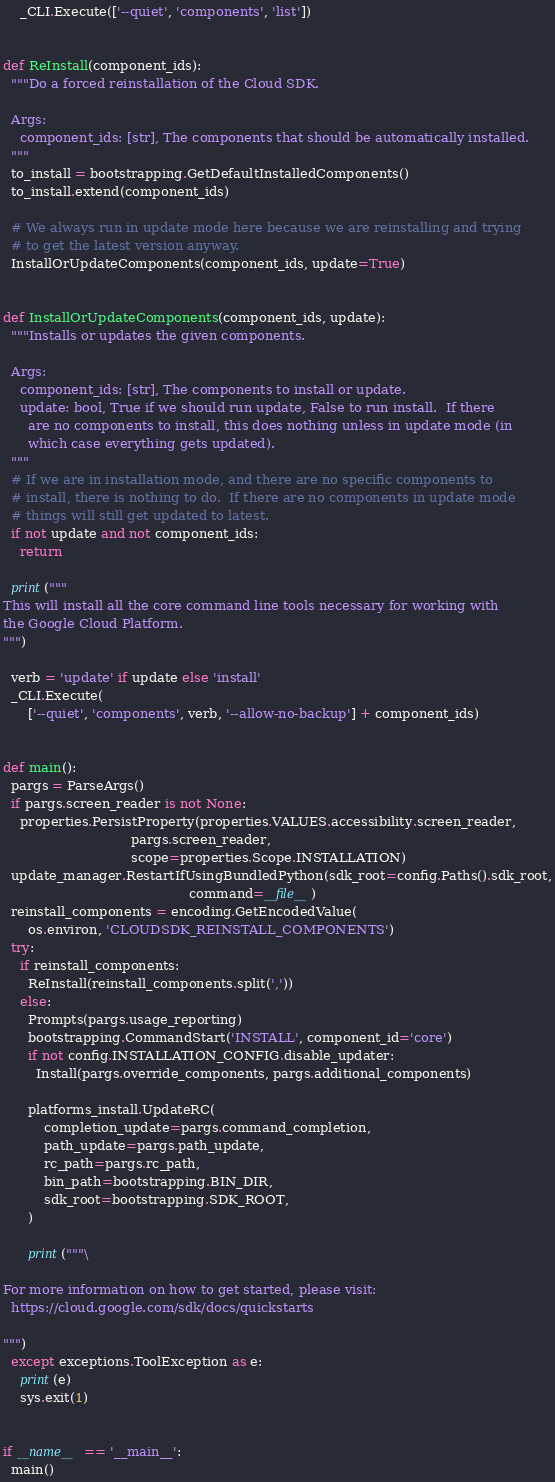Convert code to text. <code><loc_0><loc_0><loc_500><loc_500><_Python_>    _CLI.Execute(['--quiet', 'components', 'list'])


def ReInstall(component_ids):
  """Do a forced reinstallation of the Cloud SDK.

  Args:
    component_ids: [str], The components that should be automatically installed.
  """
  to_install = bootstrapping.GetDefaultInstalledComponents()
  to_install.extend(component_ids)

  # We always run in update mode here because we are reinstalling and trying
  # to get the latest version anyway.
  InstallOrUpdateComponents(component_ids, update=True)


def InstallOrUpdateComponents(component_ids, update):
  """Installs or updates the given components.

  Args:
    component_ids: [str], The components to install or update.
    update: bool, True if we should run update, False to run install.  If there
      are no components to install, this does nothing unless in update mode (in
      which case everything gets updated).
  """
  # If we are in installation mode, and there are no specific components to
  # install, there is nothing to do.  If there are no components in update mode
  # things will still get updated to latest.
  if not update and not component_ids:
    return

  print("""
This will install all the core command line tools necessary for working with
the Google Cloud Platform.
""")

  verb = 'update' if update else 'install'
  _CLI.Execute(
      ['--quiet', 'components', verb, '--allow-no-backup'] + component_ids)


def main():
  pargs = ParseArgs()
  if pargs.screen_reader is not None:
    properties.PersistProperty(properties.VALUES.accessibility.screen_reader,
                               pargs.screen_reader,
                               scope=properties.Scope.INSTALLATION)
  update_manager.RestartIfUsingBundledPython(sdk_root=config.Paths().sdk_root,
                                             command=__file__)
  reinstall_components = encoding.GetEncodedValue(
      os.environ, 'CLOUDSDK_REINSTALL_COMPONENTS')
  try:
    if reinstall_components:
      ReInstall(reinstall_components.split(','))
    else:
      Prompts(pargs.usage_reporting)
      bootstrapping.CommandStart('INSTALL', component_id='core')
      if not config.INSTALLATION_CONFIG.disable_updater:
        Install(pargs.override_components, pargs.additional_components)

      platforms_install.UpdateRC(
          completion_update=pargs.command_completion,
          path_update=pargs.path_update,
          rc_path=pargs.rc_path,
          bin_path=bootstrapping.BIN_DIR,
          sdk_root=bootstrapping.SDK_ROOT,
      )

      print("""\

For more information on how to get started, please visit:
  https://cloud.google.com/sdk/docs/quickstarts

""")
  except exceptions.ToolException as e:
    print(e)
    sys.exit(1)


if __name__ == '__main__':
  main()
</code> 